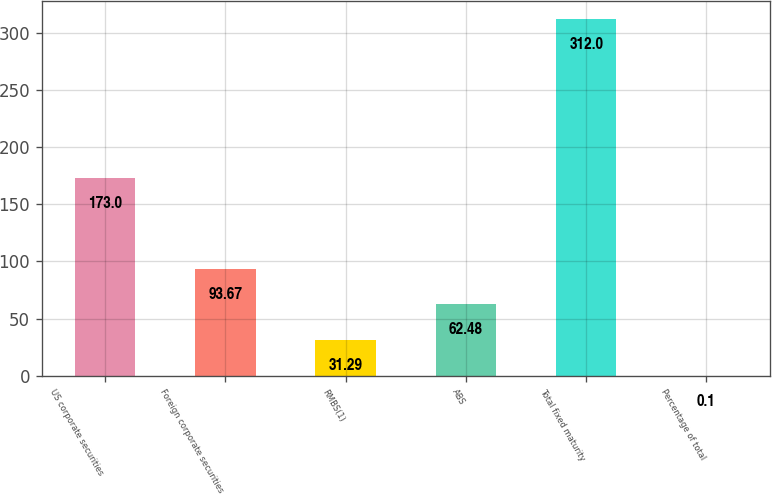<chart> <loc_0><loc_0><loc_500><loc_500><bar_chart><fcel>US corporate securities<fcel>Foreign corporate securities<fcel>RMBS(1)<fcel>ABS<fcel>Total fixed maturity<fcel>Percentage of total<nl><fcel>173<fcel>93.67<fcel>31.29<fcel>62.48<fcel>312<fcel>0.1<nl></chart> 